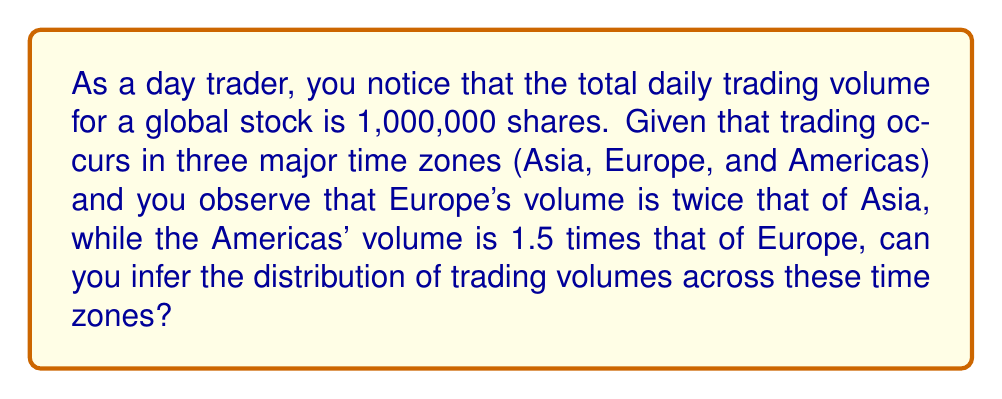Show me your answer to this math problem. Let's approach this step-by-step:

1) Let's define variables for each time zone's trading volume:
   $x$ = Asia's trading volume
   $2x$ = Europe's trading volume (given that it's twice Asia's)
   $3x$ = Americas' trading volume (1.5 times Europe's, which is $1.5 * 2x = 3x$)

2) We know the total volume is 1,000,000 shares. So we can set up an equation:

   $x + 2x + 3x = 1,000,000$

3) Simplify the left side of the equation:

   $6x = 1,000,000$

4) Solve for $x$:

   $x = 1,000,000 / 6 = 166,666.67$

5) Now we can calculate each time zone's volume:

   Asia: $x = 166,666.67$
   Europe: $2x = 2 * 166,666.67 = 333,333.33$
   Americas: $3x = 3 * 166,666.67 = 500,000$

6) To get the distribution as percentages:

   Asia: $166,666.67 / 1,000,000 * 100\% = 16.67\%$
   Europe: $333,333.33 / 1,000,000 * 100\% = 33.33\%$
   Americas: $500,000 / 1,000,000 * 100\% = 50\%$
Answer: Asia: 16.67%, Europe: 33.33%, Americas: 50% 